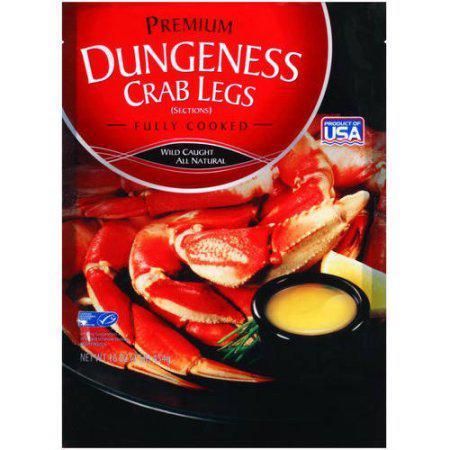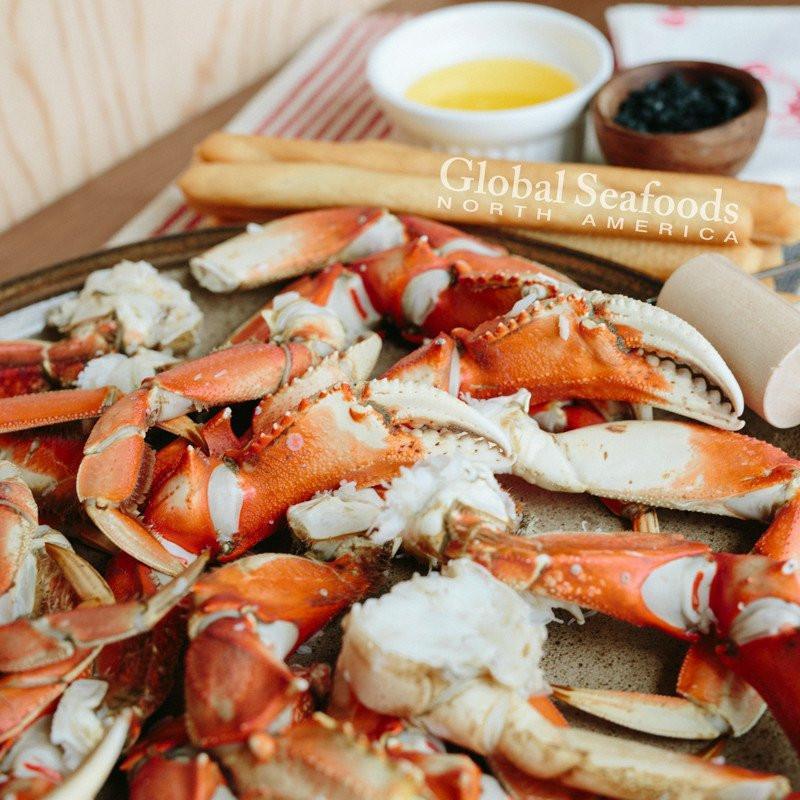The first image is the image on the left, the second image is the image on the right. Assess this claim about the two images: "There is food other than crab in both images.". Correct or not? Answer yes or no. Yes. The first image is the image on the left, the second image is the image on the right. Evaluate the accuracy of this statement regarding the images: "At least one of the images includes a small white dish of dipping sauce next to the plate of crab.". Is it true? Answer yes or no. Yes. 